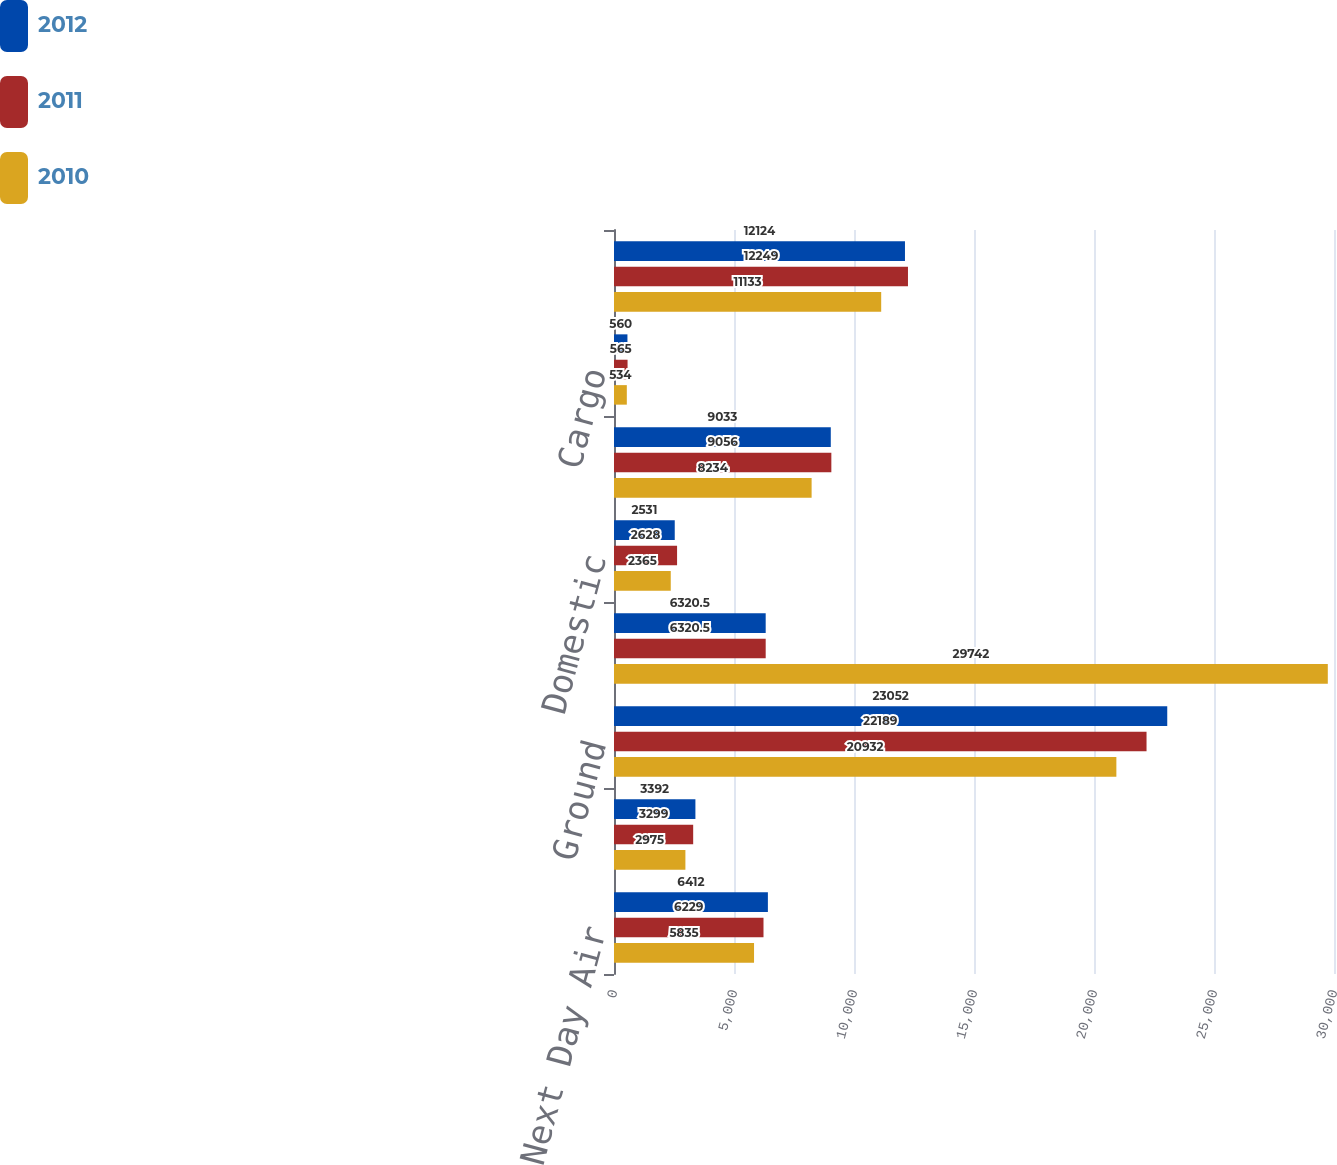Convert chart. <chart><loc_0><loc_0><loc_500><loc_500><stacked_bar_chart><ecel><fcel>Next Day Air<fcel>Deferred<fcel>Ground<fcel>Total US Domestic Package<fcel>Domestic<fcel>Export<fcel>Cargo<fcel>Total International Package<nl><fcel>2012<fcel>6412<fcel>3392<fcel>23052<fcel>6320.5<fcel>2531<fcel>9033<fcel>560<fcel>12124<nl><fcel>2011<fcel>6229<fcel>3299<fcel>22189<fcel>6320.5<fcel>2628<fcel>9056<fcel>565<fcel>12249<nl><fcel>2010<fcel>5835<fcel>2975<fcel>20932<fcel>29742<fcel>2365<fcel>8234<fcel>534<fcel>11133<nl></chart> 